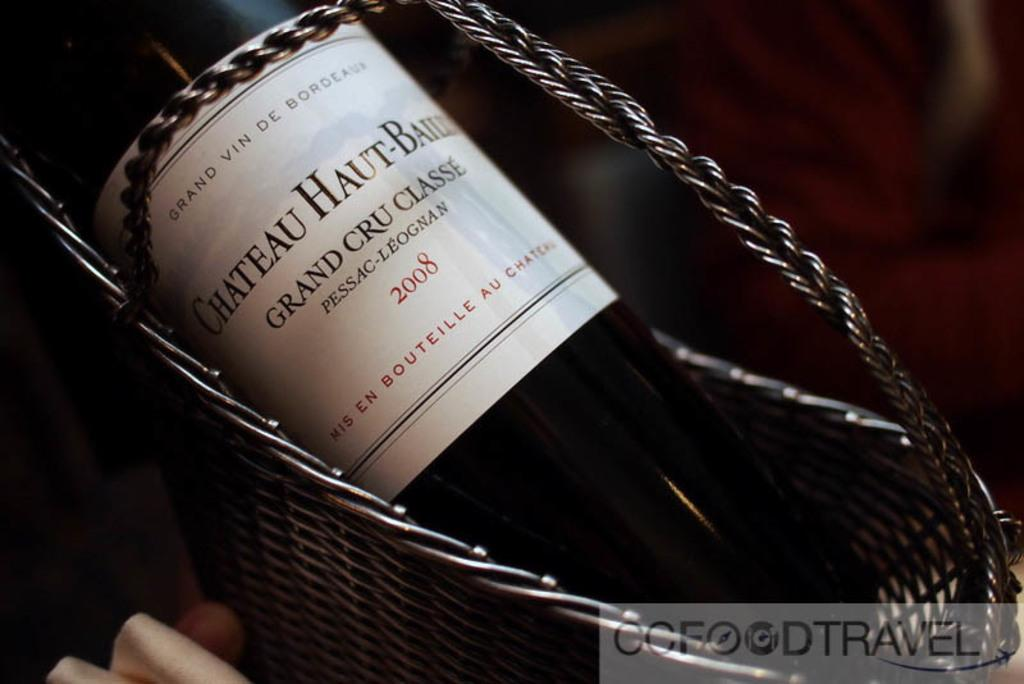<image>
Write a terse but informative summary of the picture. A bottle of Chateau Haut Grand Cru wine from 2008. 